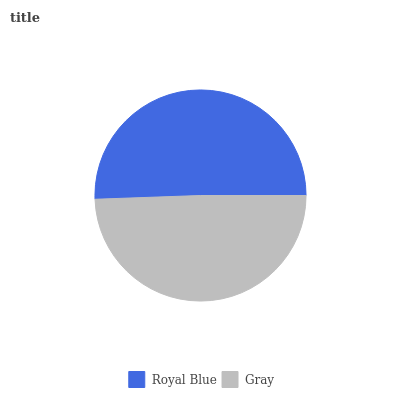Is Gray the minimum?
Answer yes or no. Yes. Is Royal Blue the maximum?
Answer yes or no. Yes. Is Gray the maximum?
Answer yes or no. No. Is Royal Blue greater than Gray?
Answer yes or no. Yes. Is Gray less than Royal Blue?
Answer yes or no. Yes. Is Gray greater than Royal Blue?
Answer yes or no. No. Is Royal Blue less than Gray?
Answer yes or no. No. Is Royal Blue the high median?
Answer yes or no. Yes. Is Gray the low median?
Answer yes or no. Yes. Is Gray the high median?
Answer yes or no. No. Is Royal Blue the low median?
Answer yes or no. No. 